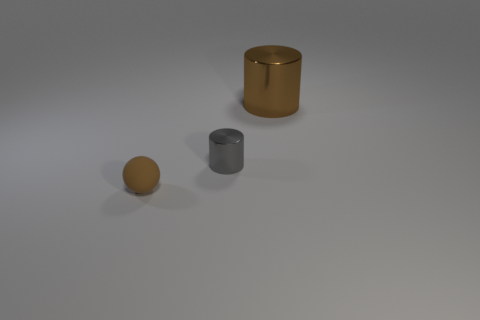Add 1 small purple shiny cylinders. How many objects exist? 4 Subtract all gray cylinders. How many cylinders are left? 1 Subtract all spheres. How many objects are left? 2 Subtract all blue balls. How many cyan cylinders are left? 0 Subtract all tiny purple metal objects. Subtract all big brown objects. How many objects are left? 2 Add 3 big brown cylinders. How many big brown cylinders are left? 4 Add 3 gray things. How many gray things exist? 4 Subtract 0 blue balls. How many objects are left? 3 Subtract 1 spheres. How many spheres are left? 0 Subtract all cyan cylinders. Subtract all yellow blocks. How many cylinders are left? 2 